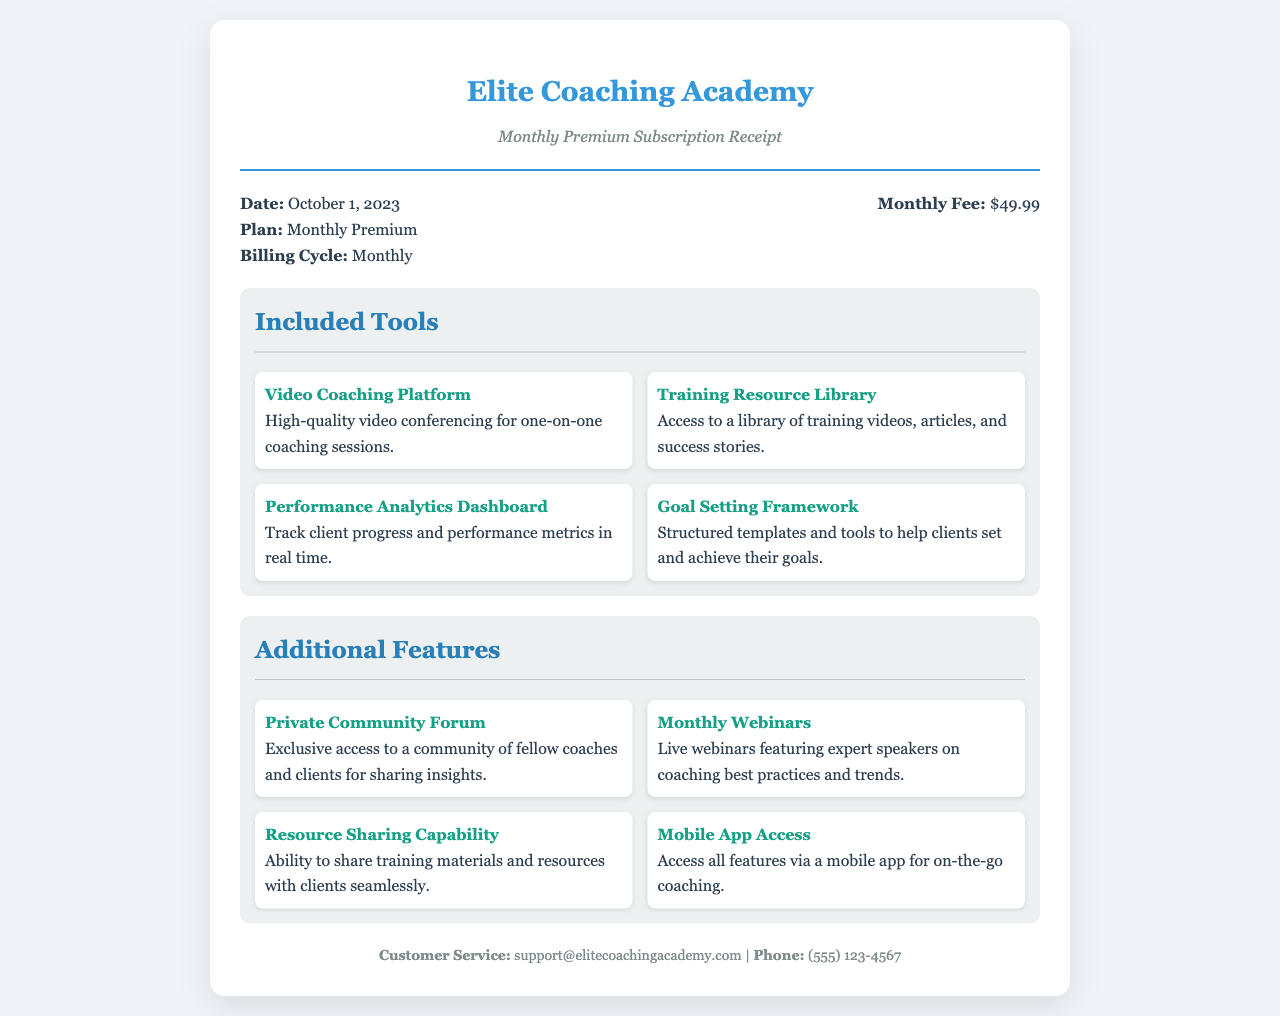What is the monthly fee? The monthly fee is stated clearly in the document.
Answer: $49.99 When was the receipt generated? The date of the receipt is provided in the details section.
Answer: October 1, 2023 What plan is mentioned in the receipt? The plan type is specified in the document details.
Answer: Monthly Premium What is one of the included tools? Specific tools included in the subscription are listed in two sections.
Answer: Video Coaching Platform How many included tools are listed? The document specifies a total number of included tools in the section.
Answer: Four What feature allows sharing materials with clients? The additional features section indicates a specific capability.
Answer: Resource Sharing Capability What type of community access is provided? The document mentions a specific community feature available to subscribers.
Answer: Private Community Forum Identify one type of educational event included. The document lists different events available as part of the subscription.
Answer: Monthly Webinars What is the contact email for customer service? Customer service contact information is included at the bottom of the receipt.
Answer: support@elitecoachingacademy.com 